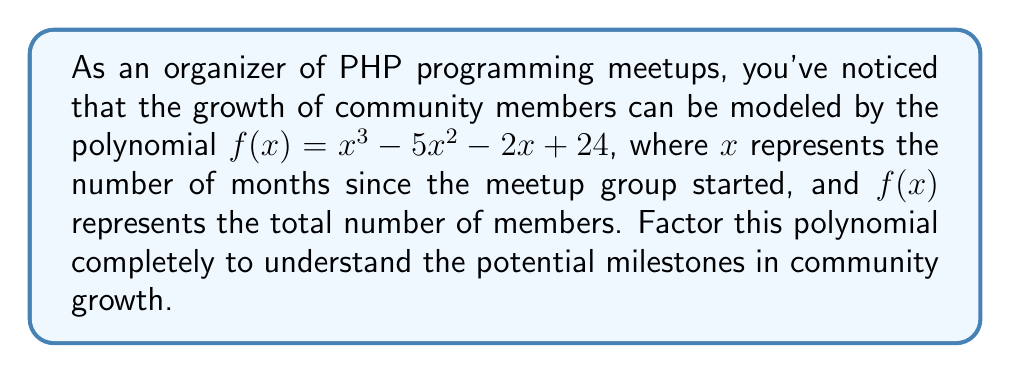Teach me how to tackle this problem. To factor this polynomial, we'll follow these steps:

1) First, let's check if there are any rational roots using the rational root theorem. The possible rational roots are the factors of the constant term: $\pm 1, \pm 2, \pm 3, \pm 4, \pm 6, \pm 8, \pm 12, \pm 24$

2) Testing these values, we find that $f(4) = 0$. So $(x - 4)$ is a factor.

3) We can use polynomial long division to divide $f(x)$ by $(x - 4)$:

   $$x^3 - 5x^2 - 2x + 24 = (x - 4)(x^2 - x - 6)$$

4) Now we need to factor the quadratic $x^2 - x - 6$. We can do this by finding two numbers that multiply to give $-6$ and add to give $-1$. These numbers are $-3$ and $2$.

5) Therefore, $x^2 - x - 6 = (x - 3)(x + 2)$

6) Combining all factors, we get:

   $$f(x) = (x - 4)(x - 3)(x + 2)$$

This factorization reveals that the community growth function has three roots: 4, 3, and -2. In the context of our PHP meetup group, these could represent significant milestones or transition points in the group's growth trajectory.
Answer: $f(x) = (x - 4)(x - 3)(x + 2)$ 